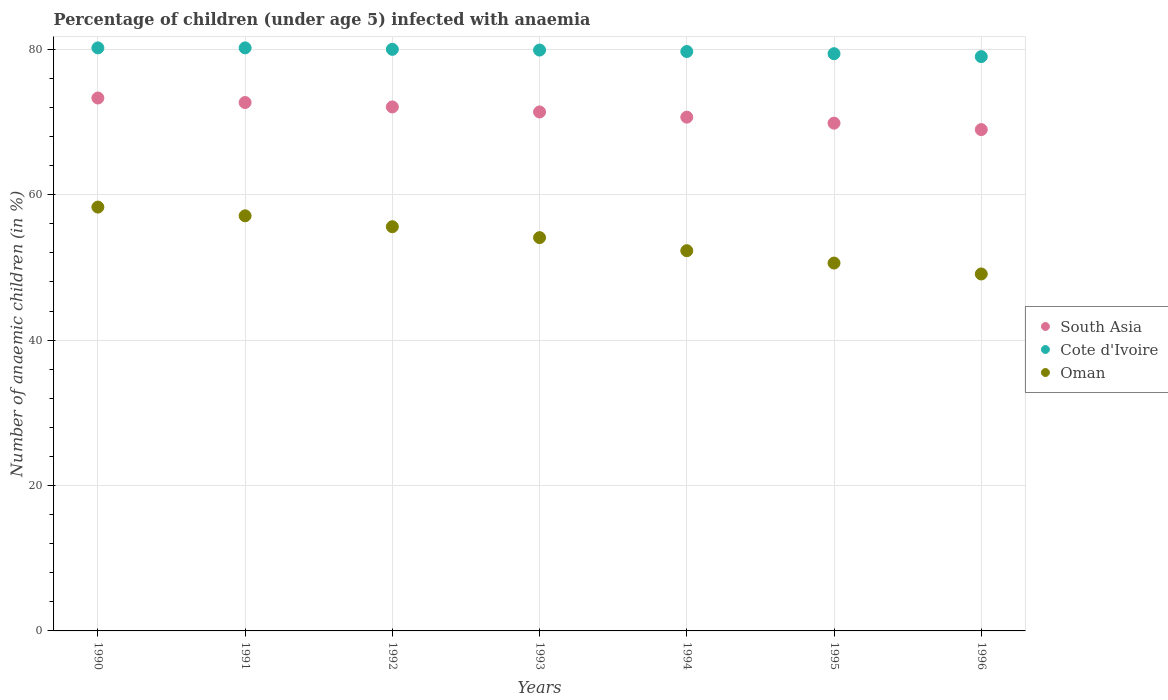What is the percentage of children infected with anaemia in in South Asia in 1990?
Make the answer very short. 73.3. Across all years, what is the maximum percentage of children infected with anaemia in in South Asia?
Give a very brief answer. 73.3. Across all years, what is the minimum percentage of children infected with anaemia in in Oman?
Give a very brief answer. 49.1. In which year was the percentage of children infected with anaemia in in South Asia minimum?
Make the answer very short. 1996. What is the total percentage of children infected with anaemia in in Oman in the graph?
Offer a terse response. 377.1. What is the difference between the percentage of children infected with anaemia in in Cote d'Ivoire in 1992 and the percentage of children infected with anaemia in in South Asia in 1995?
Give a very brief answer. 10.16. What is the average percentage of children infected with anaemia in in Cote d'Ivoire per year?
Keep it short and to the point. 79.77. In the year 1992, what is the difference between the percentage of children infected with anaemia in in South Asia and percentage of children infected with anaemia in in Cote d'Ivoire?
Give a very brief answer. -7.92. In how many years, is the percentage of children infected with anaemia in in Oman greater than 8 %?
Offer a terse response. 7. What is the ratio of the percentage of children infected with anaemia in in Cote d'Ivoire in 1991 to that in 1995?
Give a very brief answer. 1.01. What is the difference between the highest and the second highest percentage of children infected with anaemia in in Oman?
Provide a short and direct response. 1.2. What is the difference between the highest and the lowest percentage of children infected with anaemia in in South Asia?
Give a very brief answer. 4.35. In how many years, is the percentage of children infected with anaemia in in Cote d'Ivoire greater than the average percentage of children infected with anaemia in in Cote d'Ivoire taken over all years?
Keep it short and to the point. 4. Is it the case that in every year, the sum of the percentage of children infected with anaemia in in South Asia and percentage of children infected with anaemia in in Cote d'Ivoire  is greater than the percentage of children infected with anaemia in in Oman?
Provide a succinct answer. Yes. Does the percentage of children infected with anaemia in in South Asia monotonically increase over the years?
Provide a succinct answer. No. Is the percentage of children infected with anaemia in in South Asia strictly greater than the percentage of children infected with anaemia in in Oman over the years?
Your response must be concise. Yes. Is the percentage of children infected with anaemia in in Cote d'Ivoire strictly less than the percentage of children infected with anaemia in in South Asia over the years?
Keep it short and to the point. No. How many dotlines are there?
Give a very brief answer. 3. How many years are there in the graph?
Offer a terse response. 7. What is the difference between two consecutive major ticks on the Y-axis?
Offer a very short reply. 20. Does the graph contain any zero values?
Provide a short and direct response. No. Where does the legend appear in the graph?
Make the answer very short. Center right. How many legend labels are there?
Ensure brevity in your answer.  3. What is the title of the graph?
Offer a terse response. Percentage of children (under age 5) infected with anaemia. Does "Moldova" appear as one of the legend labels in the graph?
Your response must be concise. No. What is the label or title of the Y-axis?
Keep it short and to the point. Number of anaemic children (in %). What is the Number of anaemic children (in %) of South Asia in 1990?
Ensure brevity in your answer.  73.3. What is the Number of anaemic children (in %) of Cote d'Ivoire in 1990?
Provide a succinct answer. 80.2. What is the Number of anaemic children (in %) in Oman in 1990?
Your answer should be very brief. 58.3. What is the Number of anaemic children (in %) of South Asia in 1991?
Your answer should be very brief. 72.68. What is the Number of anaemic children (in %) in Cote d'Ivoire in 1991?
Ensure brevity in your answer.  80.2. What is the Number of anaemic children (in %) in Oman in 1991?
Your answer should be very brief. 57.1. What is the Number of anaemic children (in %) in South Asia in 1992?
Provide a short and direct response. 72.08. What is the Number of anaemic children (in %) of Cote d'Ivoire in 1992?
Provide a short and direct response. 80. What is the Number of anaemic children (in %) in Oman in 1992?
Make the answer very short. 55.6. What is the Number of anaemic children (in %) of South Asia in 1993?
Offer a very short reply. 71.39. What is the Number of anaemic children (in %) of Cote d'Ivoire in 1993?
Your answer should be very brief. 79.9. What is the Number of anaemic children (in %) of Oman in 1993?
Ensure brevity in your answer.  54.1. What is the Number of anaemic children (in %) in South Asia in 1994?
Make the answer very short. 70.67. What is the Number of anaemic children (in %) in Cote d'Ivoire in 1994?
Provide a short and direct response. 79.7. What is the Number of anaemic children (in %) in Oman in 1994?
Offer a very short reply. 52.3. What is the Number of anaemic children (in %) in South Asia in 1995?
Provide a succinct answer. 69.84. What is the Number of anaemic children (in %) of Cote d'Ivoire in 1995?
Offer a terse response. 79.4. What is the Number of anaemic children (in %) in Oman in 1995?
Offer a terse response. 50.6. What is the Number of anaemic children (in %) of South Asia in 1996?
Your answer should be compact. 68.96. What is the Number of anaemic children (in %) of Cote d'Ivoire in 1996?
Provide a succinct answer. 79. What is the Number of anaemic children (in %) in Oman in 1996?
Your answer should be compact. 49.1. Across all years, what is the maximum Number of anaemic children (in %) of South Asia?
Your response must be concise. 73.3. Across all years, what is the maximum Number of anaemic children (in %) of Cote d'Ivoire?
Make the answer very short. 80.2. Across all years, what is the maximum Number of anaemic children (in %) in Oman?
Your answer should be very brief. 58.3. Across all years, what is the minimum Number of anaemic children (in %) of South Asia?
Give a very brief answer. 68.96. Across all years, what is the minimum Number of anaemic children (in %) in Cote d'Ivoire?
Make the answer very short. 79. Across all years, what is the minimum Number of anaemic children (in %) in Oman?
Offer a very short reply. 49.1. What is the total Number of anaemic children (in %) of South Asia in the graph?
Offer a very short reply. 498.92. What is the total Number of anaemic children (in %) of Cote d'Ivoire in the graph?
Ensure brevity in your answer.  558.4. What is the total Number of anaemic children (in %) of Oman in the graph?
Ensure brevity in your answer.  377.1. What is the difference between the Number of anaemic children (in %) in South Asia in 1990 and that in 1991?
Your answer should be very brief. 0.62. What is the difference between the Number of anaemic children (in %) in Oman in 1990 and that in 1991?
Make the answer very short. 1.2. What is the difference between the Number of anaemic children (in %) of South Asia in 1990 and that in 1992?
Provide a succinct answer. 1.23. What is the difference between the Number of anaemic children (in %) of South Asia in 1990 and that in 1993?
Keep it short and to the point. 1.92. What is the difference between the Number of anaemic children (in %) in Cote d'Ivoire in 1990 and that in 1993?
Ensure brevity in your answer.  0.3. What is the difference between the Number of anaemic children (in %) in Oman in 1990 and that in 1993?
Your answer should be compact. 4.2. What is the difference between the Number of anaemic children (in %) in South Asia in 1990 and that in 1994?
Your response must be concise. 2.63. What is the difference between the Number of anaemic children (in %) in Cote d'Ivoire in 1990 and that in 1994?
Give a very brief answer. 0.5. What is the difference between the Number of anaemic children (in %) of South Asia in 1990 and that in 1995?
Offer a very short reply. 3.46. What is the difference between the Number of anaemic children (in %) in South Asia in 1990 and that in 1996?
Keep it short and to the point. 4.34. What is the difference between the Number of anaemic children (in %) in South Asia in 1991 and that in 1992?
Provide a short and direct response. 0.61. What is the difference between the Number of anaemic children (in %) of Oman in 1991 and that in 1992?
Your response must be concise. 1.5. What is the difference between the Number of anaemic children (in %) of South Asia in 1991 and that in 1993?
Provide a short and direct response. 1.3. What is the difference between the Number of anaemic children (in %) in Cote d'Ivoire in 1991 and that in 1993?
Keep it short and to the point. 0.3. What is the difference between the Number of anaemic children (in %) of South Asia in 1991 and that in 1994?
Give a very brief answer. 2.01. What is the difference between the Number of anaemic children (in %) in Oman in 1991 and that in 1994?
Your response must be concise. 4.8. What is the difference between the Number of anaemic children (in %) in South Asia in 1991 and that in 1995?
Offer a terse response. 2.84. What is the difference between the Number of anaemic children (in %) in South Asia in 1991 and that in 1996?
Your answer should be very brief. 3.72. What is the difference between the Number of anaemic children (in %) in Cote d'Ivoire in 1991 and that in 1996?
Offer a very short reply. 1.2. What is the difference between the Number of anaemic children (in %) of South Asia in 1992 and that in 1993?
Provide a short and direct response. 0.69. What is the difference between the Number of anaemic children (in %) of South Asia in 1992 and that in 1994?
Your answer should be very brief. 1.4. What is the difference between the Number of anaemic children (in %) of South Asia in 1992 and that in 1995?
Provide a short and direct response. 2.23. What is the difference between the Number of anaemic children (in %) of Oman in 1992 and that in 1995?
Ensure brevity in your answer.  5. What is the difference between the Number of anaemic children (in %) in South Asia in 1992 and that in 1996?
Your response must be concise. 3.12. What is the difference between the Number of anaemic children (in %) in Oman in 1992 and that in 1996?
Offer a very short reply. 6.5. What is the difference between the Number of anaemic children (in %) in South Asia in 1993 and that in 1994?
Ensure brevity in your answer.  0.71. What is the difference between the Number of anaemic children (in %) of Cote d'Ivoire in 1993 and that in 1994?
Your response must be concise. 0.2. What is the difference between the Number of anaemic children (in %) of South Asia in 1993 and that in 1995?
Your response must be concise. 1.54. What is the difference between the Number of anaemic children (in %) of Oman in 1993 and that in 1995?
Provide a short and direct response. 3.5. What is the difference between the Number of anaemic children (in %) of South Asia in 1993 and that in 1996?
Provide a succinct answer. 2.43. What is the difference between the Number of anaemic children (in %) of Oman in 1993 and that in 1996?
Ensure brevity in your answer.  5. What is the difference between the Number of anaemic children (in %) of South Asia in 1994 and that in 1995?
Your response must be concise. 0.83. What is the difference between the Number of anaemic children (in %) of Oman in 1994 and that in 1995?
Provide a succinct answer. 1.7. What is the difference between the Number of anaemic children (in %) in South Asia in 1994 and that in 1996?
Provide a short and direct response. 1.71. What is the difference between the Number of anaemic children (in %) in Oman in 1994 and that in 1996?
Give a very brief answer. 3.2. What is the difference between the Number of anaemic children (in %) in South Asia in 1995 and that in 1996?
Offer a very short reply. 0.89. What is the difference between the Number of anaemic children (in %) of Cote d'Ivoire in 1995 and that in 1996?
Give a very brief answer. 0.4. What is the difference between the Number of anaemic children (in %) of Oman in 1995 and that in 1996?
Provide a succinct answer. 1.5. What is the difference between the Number of anaemic children (in %) in South Asia in 1990 and the Number of anaemic children (in %) in Cote d'Ivoire in 1991?
Give a very brief answer. -6.9. What is the difference between the Number of anaemic children (in %) in South Asia in 1990 and the Number of anaemic children (in %) in Oman in 1991?
Your answer should be compact. 16.2. What is the difference between the Number of anaemic children (in %) of Cote d'Ivoire in 1990 and the Number of anaemic children (in %) of Oman in 1991?
Your response must be concise. 23.1. What is the difference between the Number of anaemic children (in %) in South Asia in 1990 and the Number of anaemic children (in %) in Cote d'Ivoire in 1992?
Keep it short and to the point. -6.7. What is the difference between the Number of anaemic children (in %) of South Asia in 1990 and the Number of anaemic children (in %) of Oman in 1992?
Your answer should be very brief. 17.7. What is the difference between the Number of anaemic children (in %) in Cote d'Ivoire in 1990 and the Number of anaemic children (in %) in Oman in 1992?
Give a very brief answer. 24.6. What is the difference between the Number of anaemic children (in %) of South Asia in 1990 and the Number of anaemic children (in %) of Cote d'Ivoire in 1993?
Your answer should be very brief. -6.6. What is the difference between the Number of anaemic children (in %) in South Asia in 1990 and the Number of anaemic children (in %) in Oman in 1993?
Make the answer very short. 19.2. What is the difference between the Number of anaemic children (in %) of Cote d'Ivoire in 1990 and the Number of anaemic children (in %) of Oman in 1993?
Give a very brief answer. 26.1. What is the difference between the Number of anaemic children (in %) of South Asia in 1990 and the Number of anaemic children (in %) of Cote d'Ivoire in 1994?
Give a very brief answer. -6.4. What is the difference between the Number of anaemic children (in %) of South Asia in 1990 and the Number of anaemic children (in %) of Oman in 1994?
Offer a very short reply. 21. What is the difference between the Number of anaemic children (in %) of Cote d'Ivoire in 1990 and the Number of anaemic children (in %) of Oman in 1994?
Your answer should be very brief. 27.9. What is the difference between the Number of anaemic children (in %) in South Asia in 1990 and the Number of anaemic children (in %) in Cote d'Ivoire in 1995?
Your answer should be compact. -6.1. What is the difference between the Number of anaemic children (in %) of South Asia in 1990 and the Number of anaemic children (in %) of Oman in 1995?
Make the answer very short. 22.7. What is the difference between the Number of anaemic children (in %) of Cote d'Ivoire in 1990 and the Number of anaemic children (in %) of Oman in 1995?
Offer a very short reply. 29.6. What is the difference between the Number of anaemic children (in %) in South Asia in 1990 and the Number of anaemic children (in %) in Cote d'Ivoire in 1996?
Your response must be concise. -5.7. What is the difference between the Number of anaemic children (in %) in South Asia in 1990 and the Number of anaemic children (in %) in Oman in 1996?
Give a very brief answer. 24.2. What is the difference between the Number of anaemic children (in %) in Cote d'Ivoire in 1990 and the Number of anaemic children (in %) in Oman in 1996?
Your answer should be very brief. 31.1. What is the difference between the Number of anaemic children (in %) in South Asia in 1991 and the Number of anaemic children (in %) in Cote d'Ivoire in 1992?
Provide a short and direct response. -7.32. What is the difference between the Number of anaemic children (in %) of South Asia in 1991 and the Number of anaemic children (in %) of Oman in 1992?
Your answer should be compact. 17.08. What is the difference between the Number of anaemic children (in %) of Cote d'Ivoire in 1991 and the Number of anaemic children (in %) of Oman in 1992?
Give a very brief answer. 24.6. What is the difference between the Number of anaemic children (in %) in South Asia in 1991 and the Number of anaemic children (in %) in Cote d'Ivoire in 1993?
Offer a very short reply. -7.22. What is the difference between the Number of anaemic children (in %) in South Asia in 1991 and the Number of anaemic children (in %) in Oman in 1993?
Give a very brief answer. 18.58. What is the difference between the Number of anaemic children (in %) of Cote d'Ivoire in 1991 and the Number of anaemic children (in %) of Oman in 1993?
Give a very brief answer. 26.1. What is the difference between the Number of anaemic children (in %) of South Asia in 1991 and the Number of anaemic children (in %) of Cote d'Ivoire in 1994?
Make the answer very short. -7.02. What is the difference between the Number of anaemic children (in %) of South Asia in 1991 and the Number of anaemic children (in %) of Oman in 1994?
Offer a very short reply. 20.38. What is the difference between the Number of anaemic children (in %) of Cote d'Ivoire in 1991 and the Number of anaemic children (in %) of Oman in 1994?
Your answer should be very brief. 27.9. What is the difference between the Number of anaemic children (in %) of South Asia in 1991 and the Number of anaemic children (in %) of Cote d'Ivoire in 1995?
Offer a terse response. -6.72. What is the difference between the Number of anaemic children (in %) in South Asia in 1991 and the Number of anaemic children (in %) in Oman in 1995?
Make the answer very short. 22.08. What is the difference between the Number of anaemic children (in %) of Cote d'Ivoire in 1991 and the Number of anaemic children (in %) of Oman in 1995?
Keep it short and to the point. 29.6. What is the difference between the Number of anaemic children (in %) of South Asia in 1991 and the Number of anaemic children (in %) of Cote d'Ivoire in 1996?
Offer a very short reply. -6.32. What is the difference between the Number of anaemic children (in %) in South Asia in 1991 and the Number of anaemic children (in %) in Oman in 1996?
Ensure brevity in your answer.  23.58. What is the difference between the Number of anaemic children (in %) in Cote d'Ivoire in 1991 and the Number of anaemic children (in %) in Oman in 1996?
Your answer should be very brief. 31.1. What is the difference between the Number of anaemic children (in %) of South Asia in 1992 and the Number of anaemic children (in %) of Cote d'Ivoire in 1993?
Your answer should be compact. -7.82. What is the difference between the Number of anaemic children (in %) in South Asia in 1992 and the Number of anaemic children (in %) in Oman in 1993?
Your answer should be compact. 17.98. What is the difference between the Number of anaemic children (in %) of Cote d'Ivoire in 1992 and the Number of anaemic children (in %) of Oman in 1993?
Offer a terse response. 25.9. What is the difference between the Number of anaemic children (in %) in South Asia in 1992 and the Number of anaemic children (in %) in Cote d'Ivoire in 1994?
Provide a succinct answer. -7.62. What is the difference between the Number of anaemic children (in %) in South Asia in 1992 and the Number of anaemic children (in %) in Oman in 1994?
Give a very brief answer. 19.78. What is the difference between the Number of anaemic children (in %) of Cote d'Ivoire in 1992 and the Number of anaemic children (in %) of Oman in 1994?
Offer a very short reply. 27.7. What is the difference between the Number of anaemic children (in %) in South Asia in 1992 and the Number of anaemic children (in %) in Cote d'Ivoire in 1995?
Give a very brief answer. -7.32. What is the difference between the Number of anaemic children (in %) in South Asia in 1992 and the Number of anaemic children (in %) in Oman in 1995?
Provide a short and direct response. 21.48. What is the difference between the Number of anaemic children (in %) in Cote d'Ivoire in 1992 and the Number of anaemic children (in %) in Oman in 1995?
Keep it short and to the point. 29.4. What is the difference between the Number of anaemic children (in %) in South Asia in 1992 and the Number of anaemic children (in %) in Cote d'Ivoire in 1996?
Give a very brief answer. -6.92. What is the difference between the Number of anaemic children (in %) of South Asia in 1992 and the Number of anaemic children (in %) of Oman in 1996?
Provide a succinct answer. 22.98. What is the difference between the Number of anaemic children (in %) in Cote d'Ivoire in 1992 and the Number of anaemic children (in %) in Oman in 1996?
Offer a terse response. 30.9. What is the difference between the Number of anaemic children (in %) in South Asia in 1993 and the Number of anaemic children (in %) in Cote d'Ivoire in 1994?
Ensure brevity in your answer.  -8.31. What is the difference between the Number of anaemic children (in %) in South Asia in 1993 and the Number of anaemic children (in %) in Oman in 1994?
Provide a succinct answer. 19.09. What is the difference between the Number of anaemic children (in %) in Cote d'Ivoire in 1993 and the Number of anaemic children (in %) in Oman in 1994?
Keep it short and to the point. 27.6. What is the difference between the Number of anaemic children (in %) in South Asia in 1993 and the Number of anaemic children (in %) in Cote d'Ivoire in 1995?
Your answer should be very brief. -8.01. What is the difference between the Number of anaemic children (in %) of South Asia in 1993 and the Number of anaemic children (in %) of Oman in 1995?
Make the answer very short. 20.79. What is the difference between the Number of anaemic children (in %) of Cote d'Ivoire in 1993 and the Number of anaemic children (in %) of Oman in 1995?
Keep it short and to the point. 29.3. What is the difference between the Number of anaemic children (in %) in South Asia in 1993 and the Number of anaemic children (in %) in Cote d'Ivoire in 1996?
Provide a short and direct response. -7.61. What is the difference between the Number of anaemic children (in %) of South Asia in 1993 and the Number of anaemic children (in %) of Oman in 1996?
Provide a short and direct response. 22.29. What is the difference between the Number of anaemic children (in %) of Cote d'Ivoire in 1993 and the Number of anaemic children (in %) of Oman in 1996?
Provide a succinct answer. 30.8. What is the difference between the Number of anaemic children (in %) in South Asia in 1994 and the Number of anaemic children (in %) in Cote d'Ivoire in 1995?
Ensure brevity in your answer.  -8.73. What is the difference between the Number of anaemic children (in %) in South Asia in 1994 and the Number of anaemic children (in %) in Oman in 1995?
Offer a terse response. 20.07. What is the difference between the Number of anaemic children (in %) in Cote d'Ivoire in 1994 and the Number of anaemic children (in %) in Oman in 1995?
Your answer should be compact. 29.1. What is the difference between the Number of anaemic children (in %) in South Asia in 1994 and the Number of anaemic children (in %) in Cote d'Ivoire in 1996?
Keep it short and to the point. -8.33. What is the difference between the Number of anaemic children (in %) of South Asia in 1994 and the Number of anaemic children (in %) of Oman in 1996?
Offer a terse response. 21.57. What is the difference between the Number of anaemic children (in %) in Cote d'Ivoire in 1994 and the Number of anaemic children (in %) in Oman in 1996?
Give a very brief answer. 30.6. What is the difference between the Number of anaemic children (in %) of South Asia in 1995 and the Number of anaemic children (in %) of Cote d'Ivoire in 1996?
Ensure brevity in your answer.  -9.16. What is the difference between the Number of anaemic children (in %) of South Asia in 1995 and the Number of anaemic children (in %) of Oman in 1996?
Your answer should be very brief. 20.74. What is the difference between the Number of anaemic children (in %) in Cote d'Ivoire in 1995 and the Number of anaemic children (in %) in Oman in 1996?
Ensure brevity in your answer.  30.3. What is the average Number of anaemic children (in %) in South Asia per year?
Your answer should be compact. 71.27. What is the average Number of anaemic children (in %) of Cote d'Ivoire per year?
Keep it short and to the point. 79.77. What is the average Number of anaemic children (in %) in Oman per year?
Provide a short and direct response. 53.87. In the year 1990, what is the difference between the Number of anaemic children (in %) in South Asia and Number of anaemic children (in %) in Cote d'Ivoire?
Provide a short and direct response. -6.9. In the year 1990, what is the difference between the Number of anaemic children (in %) of South Asia and Number of anaemic children (in %) of Oman?
Offer a terse response. 15. In the year 1990, what is the difference between the Number of anaemic children (in %) of Cote d'Ivoire and Number of anaemic children (in %) of Oman?
Provide a succinct answer. 21.9. In the year 1991, what is the difference between the Number of anaemic children (in %) of South Asia and Number of anaemic children (in %) of Cote d'Ivoire?
Offer a terse response. -7.52. In the year 1991, what is the difference between the Number of anaemic children (in %) in South Asia and Number of anaemic children (in %) in Oman?
Provide a succinct answer. 15.58. In the year 1991, what is the difference between the Number of anaemic children (in %) of Cote d'Ivoire and Number of anaemic children (in %) of Oman?
Provide a succinct answer. 23.1. In the year 1992, what is the difference between the Number of anaemic children (in %) of South Asia and Number of anaemic children (in %) of Cote d'Ivoire?
Offer a terse response. -7.92. In the year 1992, what is the difference between the Number of anaemic children (in %) in South Asia and Number of anaemic children (in %) in Oman?
Ensure brevity in your answer.  16.48. In the year 1992, what is the difference between the Number of anaemic children (in %) of Cote d'Ivoire and Number of anaemic children (in %) of Oman?
Offer a terse response. 24.4. In the year 1993, what is the difference between the Number of anaemic children (in %) in South Asia and Number of anaemic children (in %) in Cote d'Ivoire?
Your answer should be compact. -8.51. In the year 1993, what is the difference between the Number of anaemic children (in %) of South Asia and Number of anaemic children (in %) of Oman?
Give a very brief answer. 17.29. In the year 1993, what is the difference between the Number of anaemic children (in %) of Cote d'Ivoire and Number of anaemic children (in %) of Oman?
Keep it short and to the point. 25.8. In the year 1994, what is the difference between the Number of anaemic children (in %) of South Asia and Number of anaemic children (in %) of Cote d'Ivoire?
Your response must be concise. -9.03. In the year 1994, what is the difference between the Number of anaemic children (in %) in South Asia and Number of anaemic children (in %) in Oman?
Give a very brief answer. 18.37. In the year 1994, what is the difference between the Number of anaemic children (in %) of Cote d'Ivoire and Number of anaemic children (in %) of Oman?
Your answer should be very brief. 27.4. In the year 1995, what is the difference between the Number of anaemic children (in %) in South Asia and Number of anaemic children (in %) in Cote d'Ivoire?
Offer a terse response. -9.56. In the year 1995, what is the difference between the Number of anaemic children (in %) in South Asia and Number of anaemic children (in %) in Oman?
Keep it short and to the point. 19.24. In the year 1995, what is the difference between the Number of anaemic children (in %) in Cote d'Ivoire and Number of anaemic children (in %) in Oman?
Your response must be concise. 28.8. In the year 1996, what is the difference between the Number of anaemic children (in %) of South Asia and Number of anaemic children (in %) of Cote d'Ivoire?
Provide a succinct answer. -10.04. In the year 1996, what is the difference between the Number of anaemic children (in %) in South Asia and Number of anaemic children (in %) in Oman?
Provide a short and direct response. 19.86. In the year 1996, what is the difference between the Number of anaemic children (in %) in Cote d'Ivoire and Number of anaemic children (in %) in Oman?
Give a very brief answer. 29.9. What is the ratio of the Number of anaemic children (in %) in South Asia in 1990 to that in 1991?
Make the answer very short. 1.01. What is the ratio of the Number of anaemic children (in %) in Cote d'Ivoire in 1990 to that in 1991?
Provide a succinct answer. 1. What is the ratio of the Number of anaemic children (in %) of South Asia in 1990 to that in 1992?
Keep it short and to the point. 1.02. What is the ratio of the Number of anaemic children (in %) in Oman in 1990 to that in 1992?
Provide a short and direct response. 1.05. What is the ratio of the Number of anaemic children (in %) of South Asia in 1990 to that in 1993?
Ensure brevity in your answer.  1.03. What is the ratio of the Number of anaemic children (in %) in Cote d'Ivoire in 1990 to that in 1993?
Offer a very short reply. 1. What is the ratio of the Number of anaemic children (in %) in Oman in 1990 to that in 1993?
Offer a very short reply. 1.08. What is the ratio of the Number of anaemic children (in %) in South Asia in 1990 to that in 1994?
Offer a terse response. 1.04. What is the ratio of the Number of anaemic children (in %) in Cote d'Ivoire in 1990 to that in 1994?
Offer a very short reply. 1.01. What is the ratio of the Number of anaemic children (in %) in Oman in 1990 to that in 1994?
Give a very brief answer. 1.11. What is the ratio of the Number of anaemic children (in %) in South Asia in 1990 to that in 1995?
Offer a terse response. 1.05. What is the ratio of the Number of anaemic children (in %) in Cote d'Ivoire in 1990 to that in 1995?
Keep it short and to the point. 1.01. What is the ratio of the Number of anaemic children (in %) of Oman in 1990 to that in 1995?
Ensure brevity in your answer.  1.15. What is the ratio of the Number of anaemic children (in %) of South Asia in 1990 to that in 1996?
Offer a terse response. 1.06. What is the ratio of the Number of anaemic children (in %) of Cote d'Ivoire in 1990 to that in 1996?
Give a very brief answer. 1.02. What is the ratio of the Number of anaemic children (in %) of Oman in 1990 to that in 1996?
Offer a very short reply. 1.19. What is the ratio of the Number of anaemic children (in %) of South Asia in 1991 to that in 1992?
Ensure brevity in your answer.  1.01. What is the ratio of the Number of anaemic children (in %) in Oman in 1991 to that in 1992?
Ensure brevity in your answer.  1.03. What is the ratio of the Number of anaemic children (in %) of South Asia in 1991 to that in 1993?
Ensure brevity in your answer.  1.02. What is the ratio of the Number of anaemic children (in %) of Oman in 1991 to that in 1993?
Give a very brief answer. 1.06. What is the ratio of the Number of anaemic children (in %) in South Asia in 1991 to that in 1994?
Provide a succinct answer. 1.03. What is the ratio of the Number of anaemic children (in %) of Cote d'Ivoire in 1991 to that in 1994?
Provide a succinct answer. 1.01. What is the ratio of the Number of anaemic children (in %) of Oman in 1991 to that in 1994?
Offer a terse response. 1.09. What is the ratio of the Number of anaemic children (in %) of South Asia in 1991 to that in 1995?
Provide a short and direct response. 1.04. What is the ratio of the Number of anaemic children (in %) of Oman in 1991 to that in 1995?
Offer a terse response. 1.13. What is the ratio of the Number of anaemic children (in %) of South Asia in 1991 to that in 1996?
Offer a terse response. 1.05. What is the ratio of the Number of anaemic children (in %) of Cote d'Ivoire in 1991 to that in 1996?
Your response must be concise. 1.02. What is the ratio of the Number of anaemic children (in %) of Oman in 1991 to that in 1996?
Your answer should be very brief. 1.16. What is the ratio of the Number of anaemic children (in %) of South Asia in 1992 to that in 1993?
Offer a very short reply. 1.01. What is the ratio of the Number of anaemic children (in %) of Oman in 1992 to that in 1993?
Ensure brevity in your answer.  1.03. What is the ratio of the Number of anaemic children (in %) of South Asia in 1992 to that in 1994?
Make the answer very short. 1.02. What is the ratio of the Number of anaemic children (in %) in Cote d'Ivoire in 1992 to that in 1994?
Provide a succinct answer. 1. What is the ratio of the Number of anaemic children (in %) in Oman in 1992 to that in 1994?
Provide a succinct answer. 1.06. What is the ratio of the Number of anaemic children (in %) in South Asia in 1992 to that in 1995?
Give a very brief answer. 1.03. What is the ratio of the Number of anaemic children (in %) of Cote d'Ivoire in 1992 to that in 1995?
Provide a short and direct response. 1.01. What is the ratio of the Number of anaemic children (in %) of Oman in 1992 to that in 1995?
Keep it short and to the point. 1.1. What is the ratio of the Number of anaemic children (in %) in South Asia in 1992 to that in 1996?
Provide a short and direct response. 1.05. What is the ratio of the Number of anaemic children (in %) of Cote d'Ivoire in 1992 to that in 1996?
Ensure brevity in your answer.  1.01. What is the ratio of the Number of anaemic children (in %) of Oman in 1992 to that in 1996?
Provide a short and direct response. 1.13. What is the ratio of the Number of anaemic children (in %) in Cote d'Ivoire in 1993 to that in 1994?
Provide a short and direct response. 1. What is the ratio of the Number of anaemic children (in %) of Oman in 1993 to that in 1994?
Your answer should be very brief. 1.03. What is the ratio of the Number of anaemic children (in %) of South Asia in 1993 to that in 1995?
Provide a short and direct response. 1.02. What is the ratio of the Number of anaemic children (in %) of Oman in 1993 to that in 1995?
Your answer should be compact. 1.07. What is the ratio of the Number of anaemic children (in %) in South Asia in 1993 to that in 1996?
Provide a short and direct response. 1.04. What is the ratio of the Number of anaemic children (in %) of Cote d'Ivoire in 1993 to that in 1996?
Ensure brevity in your answer.  1.01. What is the ratio of the Number of anaemic children (in %) of Oman in 1993 to that in 1996?
Your response must be concise. 1.1. What is the ratio of the Number of anaemic children (in %) of South Asia in 1994 to that in 1995?
Provide a succinct answer. 1.01. What is the ratio of the Number of anaemic children (in %) in Oman in 1994 to that in 1995?
Give a very brief answer. 1.03. What is the ratio of the Number of anaemic children (in %) of South Asia in 1994 to that in 1996?
Provide a short and direct response. 1.02. What is the ratio of the Number of anaemic children (in %) of Cote d'Ivoire in 1994 to that in 1996?
Your response must be concise. 1.01. What is the ratio of the Number of anaemic children (in %) of Oman in 1994 to that in 1996?
Provide a succinct answer. 1.07. What is the ratio of the Number of anaemic children (in %) in South Asia in 1995 to that in 1996?
Provide a succinct answer. 1.01. What is the ratio of the Number of anaemic children (in %) in Cote d'Ivoire in 1995 to that in 1996?
Your answer should be compact. 1.01. What is the ratio of the Number of anaemic children (in %) in Oman in 1995 to that in 1996?
Provide a succinct answer. 1.03. What is the difference between the highest and the second highest Number of anaemic children (in %) in South Asia?
Provide a succinct answer. 0.62. What is the difference between the highest and the lowest Number of anaemic children (in %) in South Asia?
Provide a succinct answer. 4.34. 